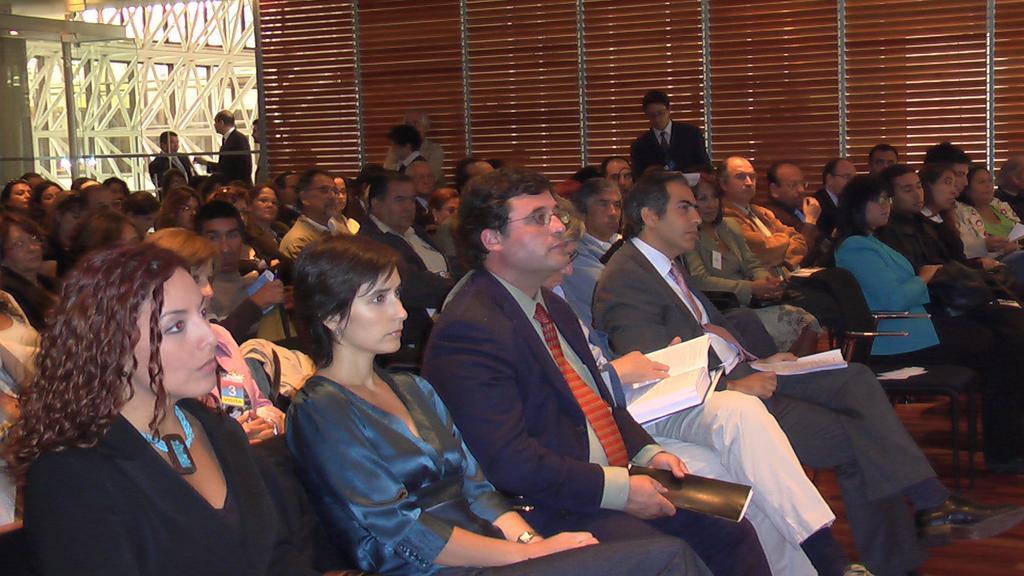Describe this image in one or two sentences. In the foreground, I can see a group of people are sitting on the chairs and are holding some objects in their hand. In the background, I can see metal rods, pillar, fence and some objects. This image is taken, maybe in a hall. 